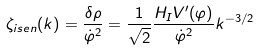Convert formula to latex. <formula><loc_0><loc_0><loc_500><loc_500>\zeta _ { i s e n } ( k ) = \frac { \delta \rho } { \dot { \varphi } ^ { 2 } } = \frac { 1 } { \sqrt { 2 } } \frac { H _ { I } V ^ { \prime } ( \varphi ) } { \dot { \varphi } ^ { 2 } } k ^ { - 3 / 2 }</formula> 